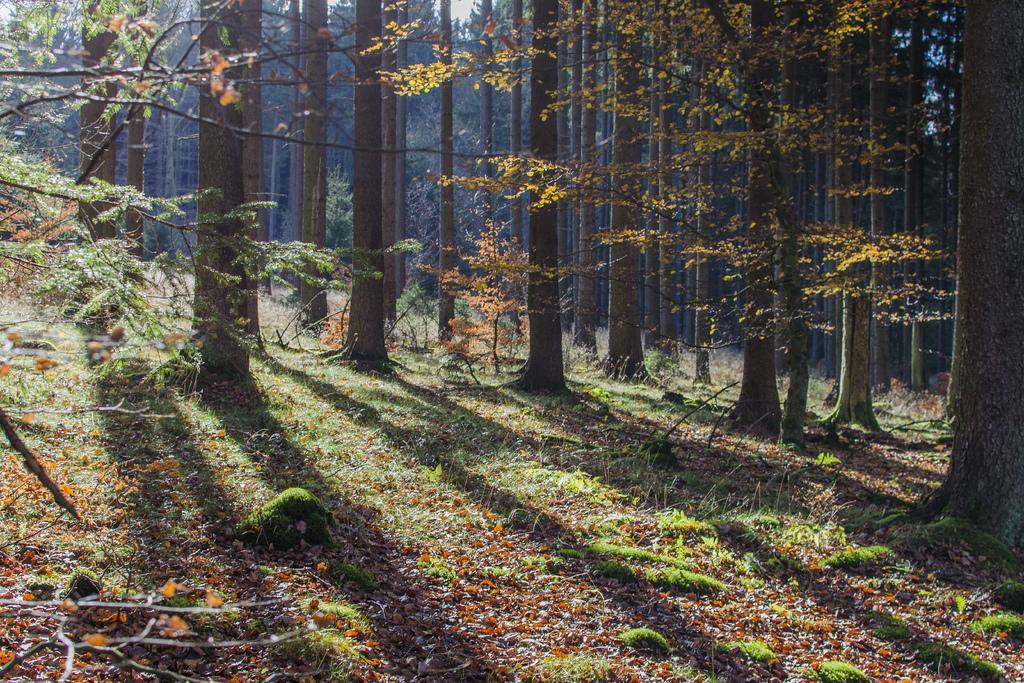Could you give a brief overview of what you see in this image? In this picture we can see some trees, at the bottom there are some leaves and grass. 